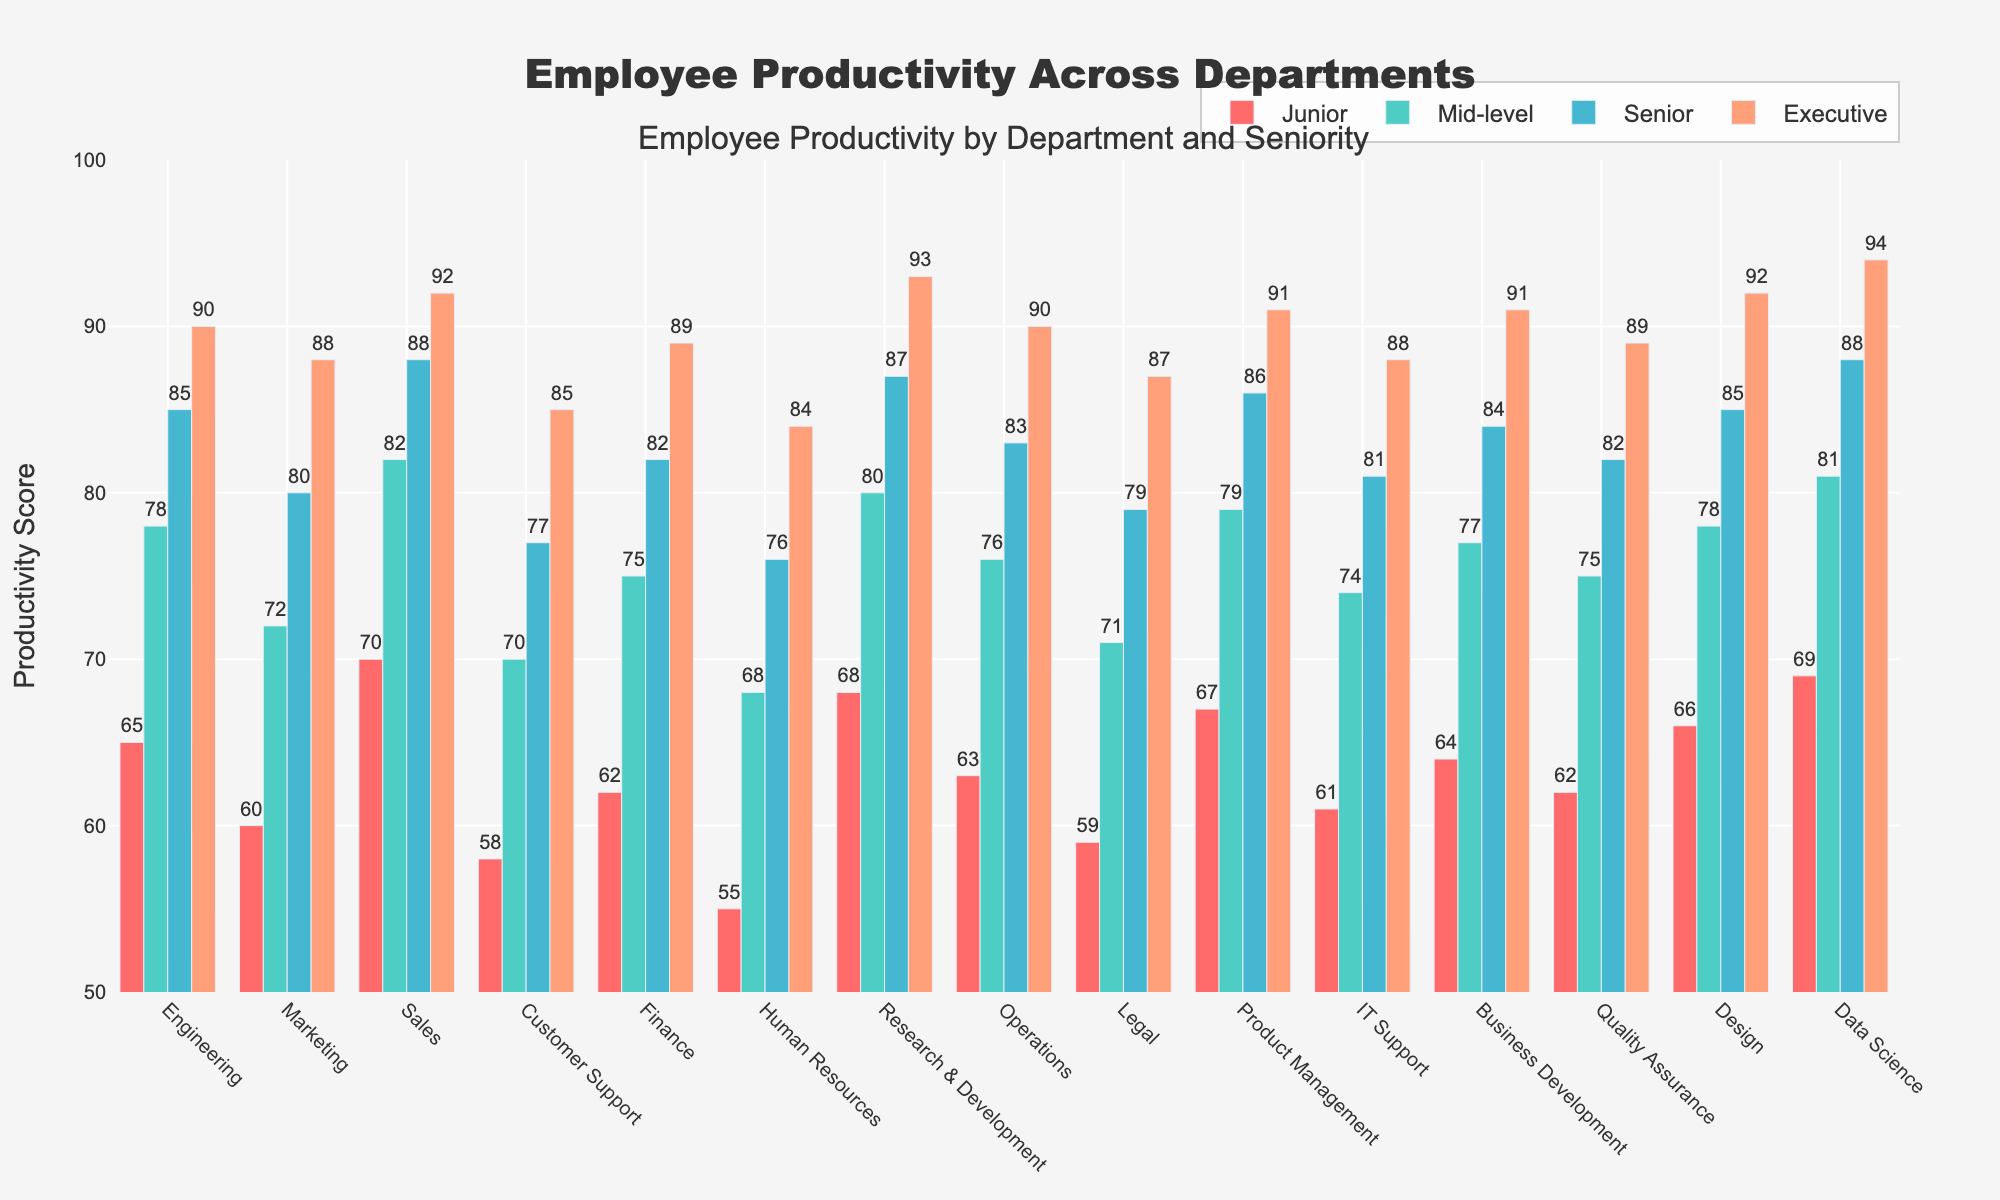What department has the highest productivity score for Senior employees? The bar for the Data Science department corresponding to Senior employees is the tallest among all departments.
Answer: Data Science Which department shows the smallest difference in productivity scores between Junior and Executive employees? Calculate the difference for each department and find the smallest one: Engineering (25), Marketing (28), Sales (22), Customer Support (27), Finance (27), Human Resources (29), Research & Development (25), Operations (27), Legal (28), Product Management (24), IT Support (27), Business Development (27), Quality Assurance (27), Design (26), Data Science (25). The smallest difference is for Sales with 22.
Answer: Sales What is the average productivity score of all Junior employees? Sum up the productivity scores for Junior employees across all departments and divide by the number of departments: (65 + 60 + 70 + 58 + 62 + 55 + 68 + 63 + 59 + 67 + 61 + 64 + 62 + 66 + 69) / 15 = 65.13
Answer: 65.13 Which seniority level in Marketing has productivity closest to 75? Compare the productivity scores in Marketing: Junior (60), Mid-level (72), Senior (80), Executive (88). Mid-level at 72 is closest to 75.
Answer: Mid-level Which department's Mid-level employees have a productivity score higher than 75 but lower than 80? Scan through the Mid-level productivity scores: Engineering (78), Sales (82), Customer Support (70), Marketing (72), Finance (75 ineligible), Human Resources (68), Research & Development (80 ineligible), Operations (76), Legal (71), Product Management (79), IT Support (74), Business Development (77), Quality Assurance (75 ineligible), Design (78), Data Science (81 ineligible). The eligible departments are Operations (76), and Product Management (79).
Answer: Operations, Product Management Which department has Junior employees with a productivity score exactly equal to the average productivity score of all existing Junior employees? The average productivity for Junior employees is 65.13. Compare it with individual Junior productivity scores: Engineering (65), Marketing (60), Sales (70), Customer Support (58), or any other. The Department Engineering has exactly 65.
Answer: Engineering Which seniority level experiences the highest increase in productivity from Junior to Executive in any one department? Calculate the increase for each department and seniority level: Engineering (25), Marketing (28), Sales (22), Customer Support (27), Finance (27), Human Resources (29), Research & Development (25), Operations (27), Legal (28), Product Management (24), IT Support (27), Business Development (27), Quality Assurance (27), Design (26), Data Science (25). Human Resources experiences the highest increase with 29.
Answer: Mid to Junior (Human Resources) How does the productivity of Mid-level employees in Customer Support compare to that in IT Support? Compare the scores: Customer Support (70) and IT Support (74). IT Support has a higher productivity score than Customer Support for Mid-level employees.
Answer: IT Support What is the total productivity score for Executive employees in the first five departments listed? Sum up the productivity scores for Executive employees in the first five departments: Engineering (90), Marketing (88), Sales (92), Customer Support (85), and Finance (89). The total is 90 + 88 + 92 + 85 + 89 = 444.
Answer: 444 